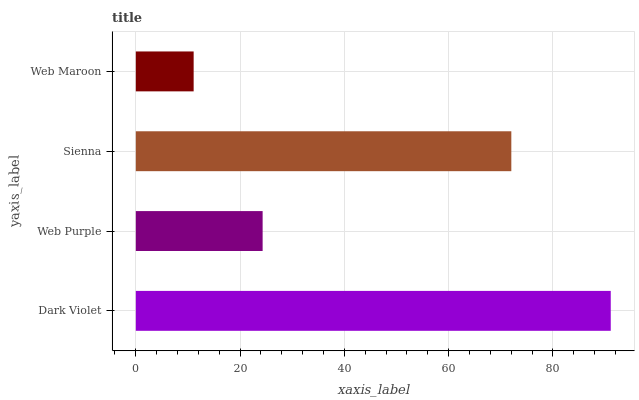Is Web Maroon the minimum?
Answer yes or no. Yes. Is Dark Violet the maximum?
Answer yes or no. Yes. Is Web Purple the minimum?
Answer yes or no. No. Is Web Purple the maximum?
Answer yes or no. No. Is Dark Violet greater than Web Purple?
Answer yes or no. Yes. Is Web Purple less than Dark Violet?
Answer yes or no. Yes. Is Web Purple greater than Dark Violet?
Answer yes or no. No. Is Dark Violet less than Web Purple?
Answer yes or no. No. Is Sienna the high median?
Answer yes or no. Yes. Is Web Purple the low median?
Answer yes or no. Yes. Is Web Purple the high median?
Answer yes or no. No. Is Sienna the low median?
Answer yes or no. No. 